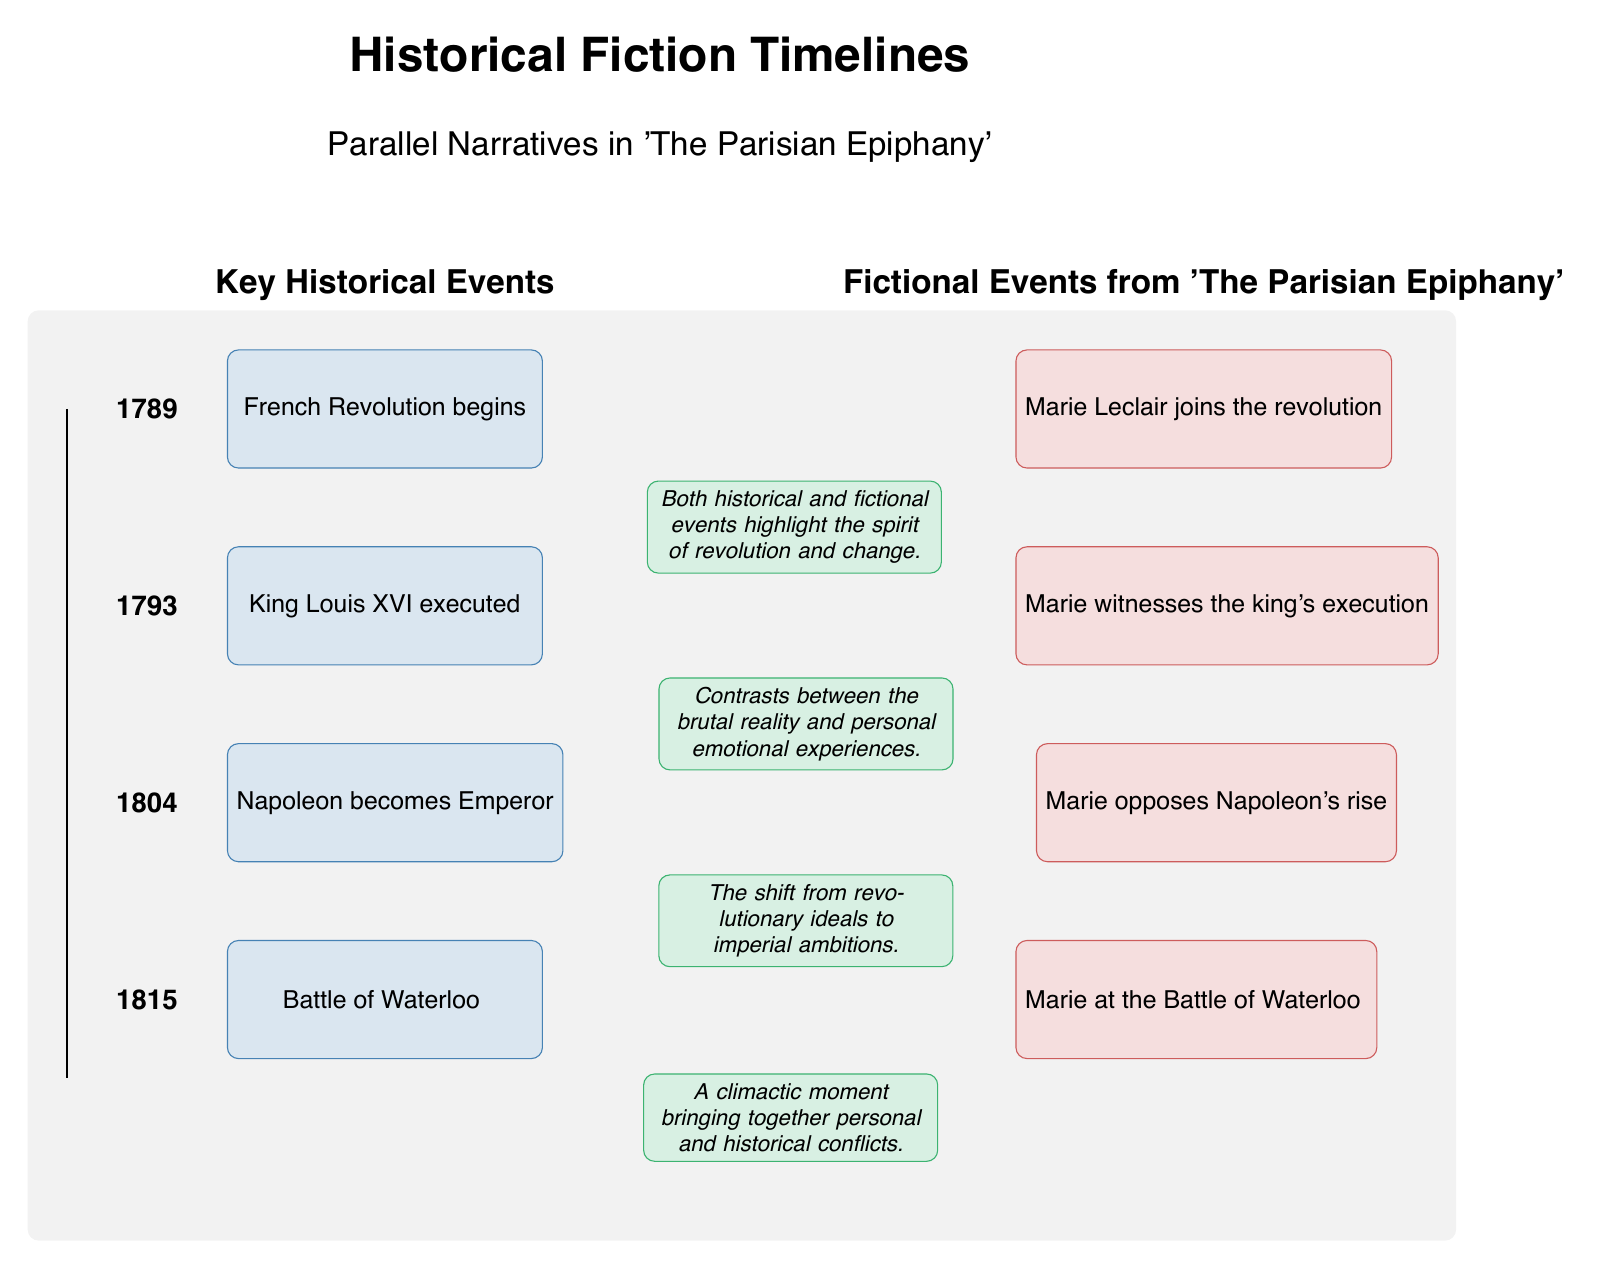What historical event occurred in 1793? The diagram labels the event of 1793 as "King Louis XVI executed," providing direct information from the historical events timeline.
Answer: King Louis XVI executed What fictional event is related to the year 1793? In the section for fictional events, the entry for 1793 states "Marie witnesses the king's execution," indicating the relationship between the fictional narrative and the historical event.
Answer: Marie witnesses the king's execution How many historical events are depicted in the timeline? By counting the number of distinct historical events listed in the diagram, it is clear that there are four separate entries.
Answer: 4 Which fictional event corresponds to Napoleon becoming Emperor? The fictional event aligned with 1804 indicates "Marie opposes Napoleon's rise," directly connecting the fictional narrative to this significant historical event.
Answer: Marie opposes Napoleon's rise What is the main theme highlighted in the annotation for the year 1789? The annotation for 1789 states, "Both historical and fictional events highlight the spirit of revolution and change," summarizing the thematic focus of that year.
Answer: Spirit of revolution and change What color represents historical events in the diagram? The historical events are depicted in a light blue shade, as indicated by the description of the event style settings in the diagram's code.
Answer: Light blue How does the fictional event of 1815 relate to historical events? The fictional event "Marie at the Battle of Waterloo" aligns with the historical event of 1815, which is the "Battle of Waterloo," indicating a direct connection between Marie's experience and the historical context.
Answer: Battle of Waterloo What can be inferred about the year 1804 based on the annotations? The annotation reads, "The shift from revolutionary ideals to imperial ambitions," suggesting that this year marked a significant transition in the narrative.
Answer: Shift from revolutionary ideals to imperial ambitions What is the purpose of the annotations in the timeline? The annotations provide context and deeper insights into the connections between historical and fictional events, enhancing the reader's understanding of the narrative structure within the timeline.
Answer: Context and insights 